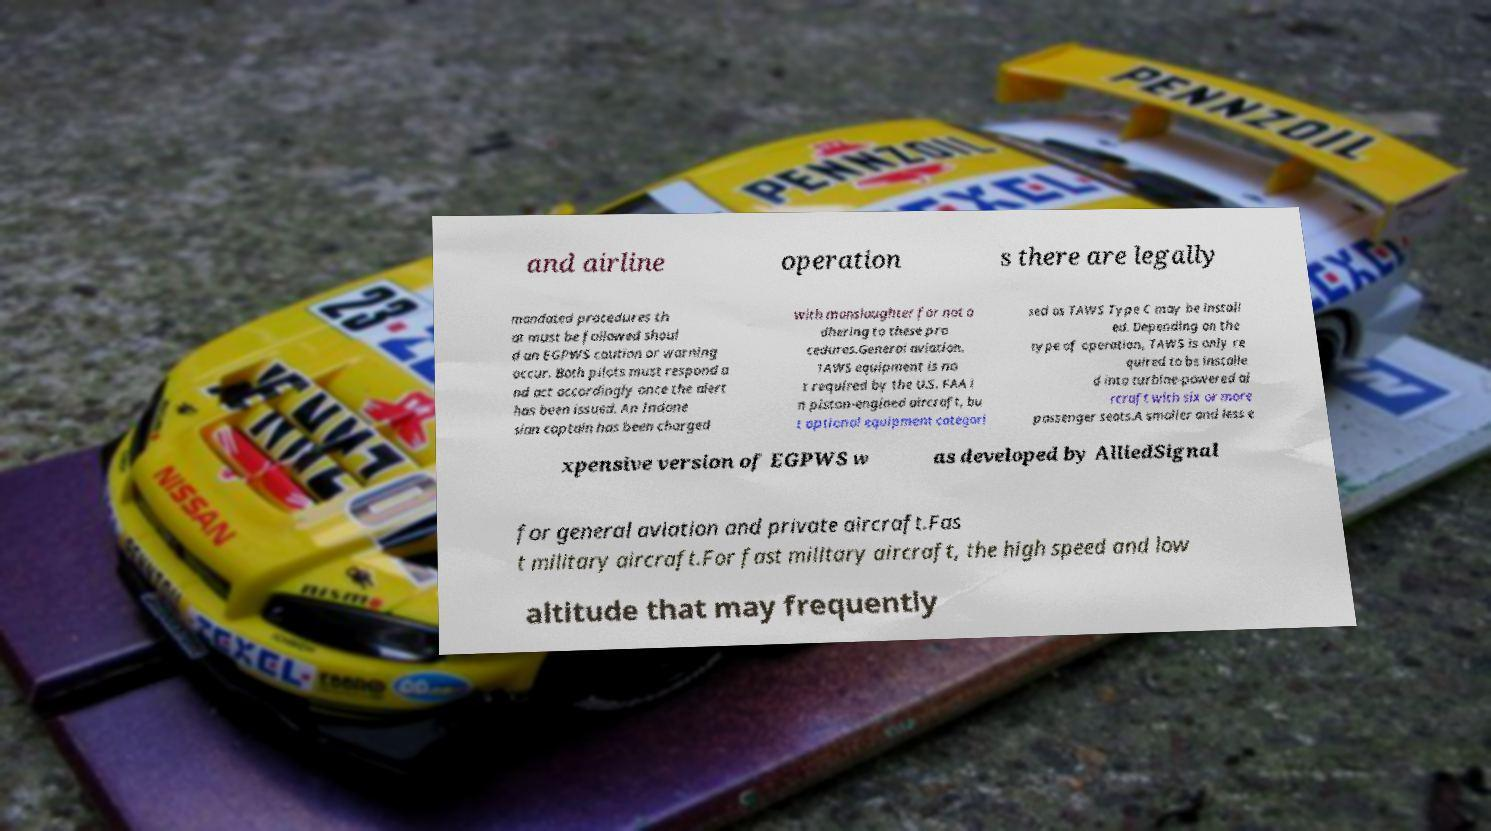I need the written content from this picture converted into text. Can you do that? and airline operation s there are legally mandated procedures th at must be followed shoul d an EGPWS caution or warning occur. Both pilots must respond a nd act accordingly once the alert has been issued. An Indone sian captain has been charged with manslaughter for not a dhering to these pro cedures.General aviation. TAWS equipment is no t required by the U.S. FAA i n piston-engined aircraft, bu t optional equipment categori sed as TAWS Type C may be install ed. Depending on the type of operation, TAWS is only re quired to be installe d into turbine-powered ai rcraft with six or more passenger seats.A smaller and less e xpensive version of EGPWS w as developed by AlliedSignal for general aviation and private aircraft.Fas t military aircraft.For fast military aircraft, the high speed and low altitude that may frequently 